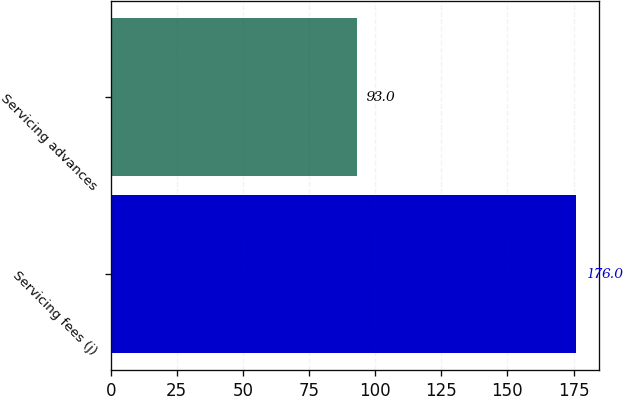Convert chart to OTSL. <chart><loc_0><loc_0><loc_500><loc_500><bar_chart><fcel>Servicing fees (j)<fcel>Servicing advances<nl><fcel>176<fcel>93<nl></chart> 